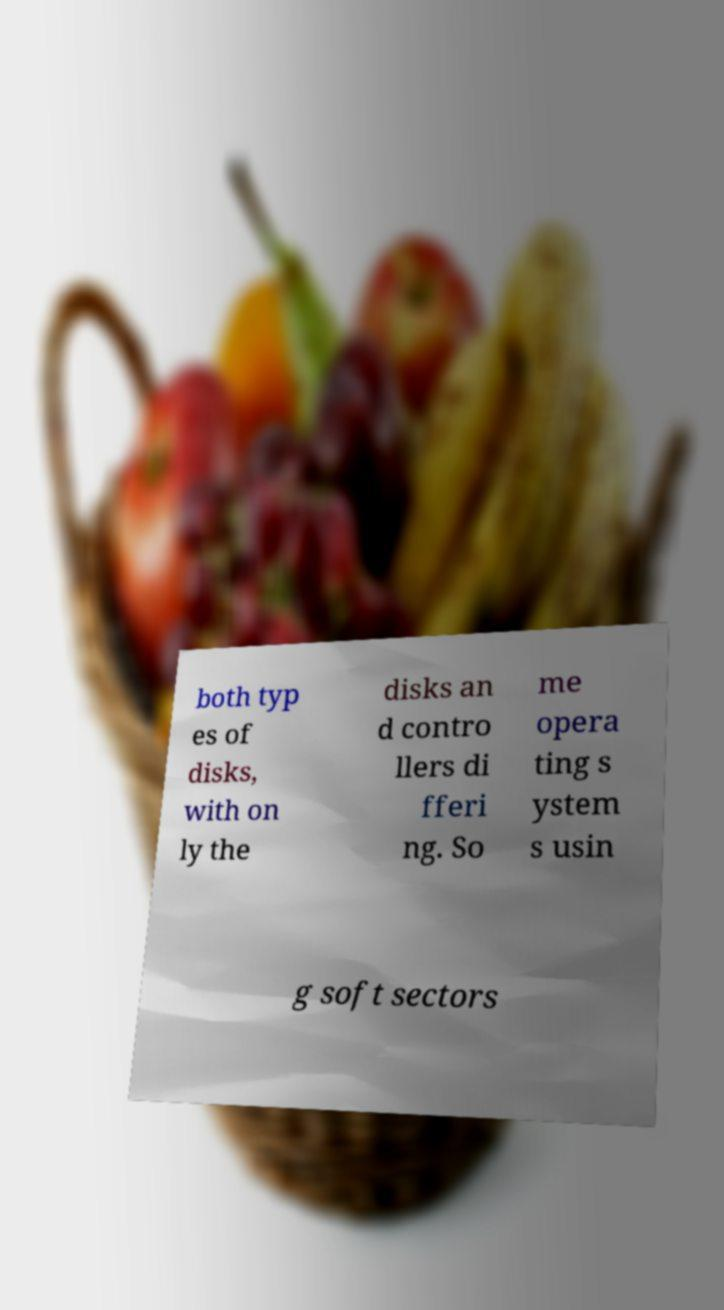Please identify and transcribe the text found in this image. both typ es of disks, with on ly the disks an d contro llers di fferi ng. So me opera ting s ystem s usin g soft sectors 